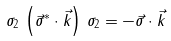Convert formula to latex. <formula><loc_0><loc_0><loc_500><loc_500>\sigma _ { 2 } \, \left ( { \vec { \sigma } } ^ { * } \cdot { \vec { k } } \right ) \, \sigma _ { 2 } = - { \vec { \sigma } } \cdot { \vec { k } }</formula> 